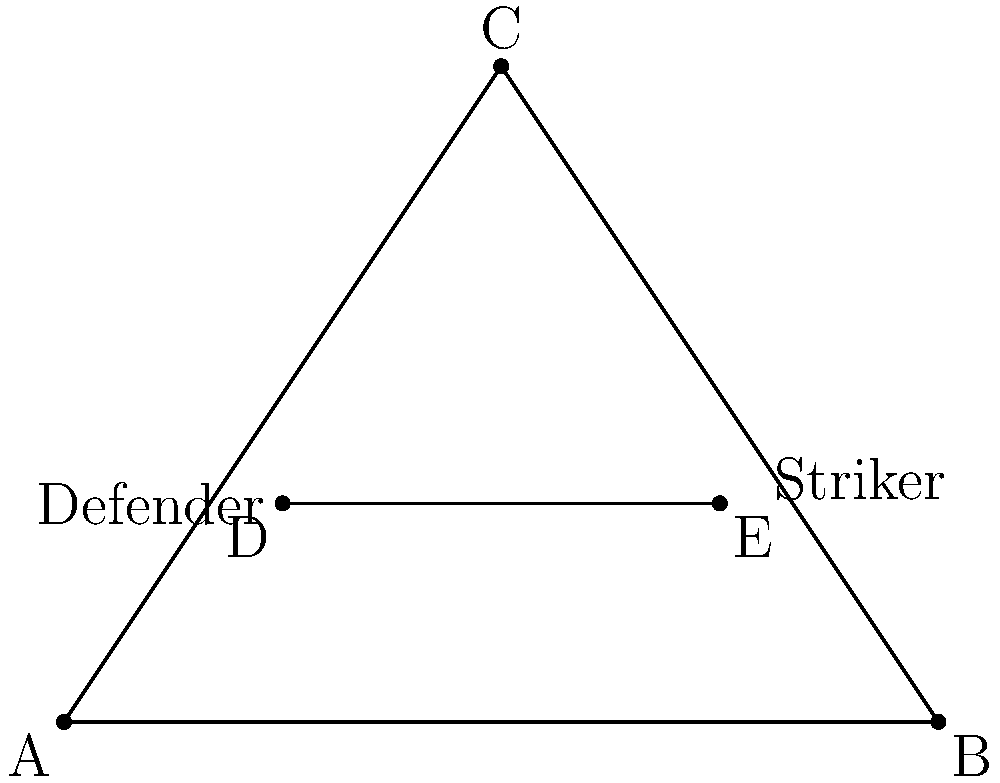As a team leader, you're designing a new formation for an upcoming match. The diagram shows a triangular field formation (ABC) with two players (D and E) positioned inside. If the area of triangle ABC is 6 square units, what is the ratio of the areas of triangles ADE to CDE, rounded to two decimal places? To solve this problem, we'll follow these steps:

1) First, we need to find the coordinates of all points. From the diagram:
   A(0,0), B(4,0), C(2,3), D(1,1), E(3,1)

2) To calculate the areas of triangles ADE and CDE, we can use the formula:
   Area = $\frac{1}{2}|x_1(y_2 - y_3) + x_2(y_3 - y_1) + x_3(y_1 - y_2)|$

3) For triangle ADE:
   Area_ADE = $\frac{1}{2}|0(1-1) + 1(1-0) + 3(0-1)| = \frac{1}{2}|-1.5| = 0.75$

4) For triangle CDE:
   Area_CDE = $\frac{1}{2}|2(1-1) + 1(1-3) + 3(3-1)| = \frac{1}{2}|4| = 2$

5) The ratio of the areas is:
   Ratio = Area_ADE : Area_CDE = 0.75 : 2 = 0.375 : 1

6) Rounded to two decimal places: 0.38 : 1

This ratio shows that triangle CDE is larger than triangle ADE, indicating that the striker (E) is positioned closer to the defender (D) than to the apex of the formation (C). As a team leader with a strong work ethic, this formation encourages close cooperation between the striker and defender while maintaining an expansive triangular shape for the overall team structure.
Answer: 0.38:1 